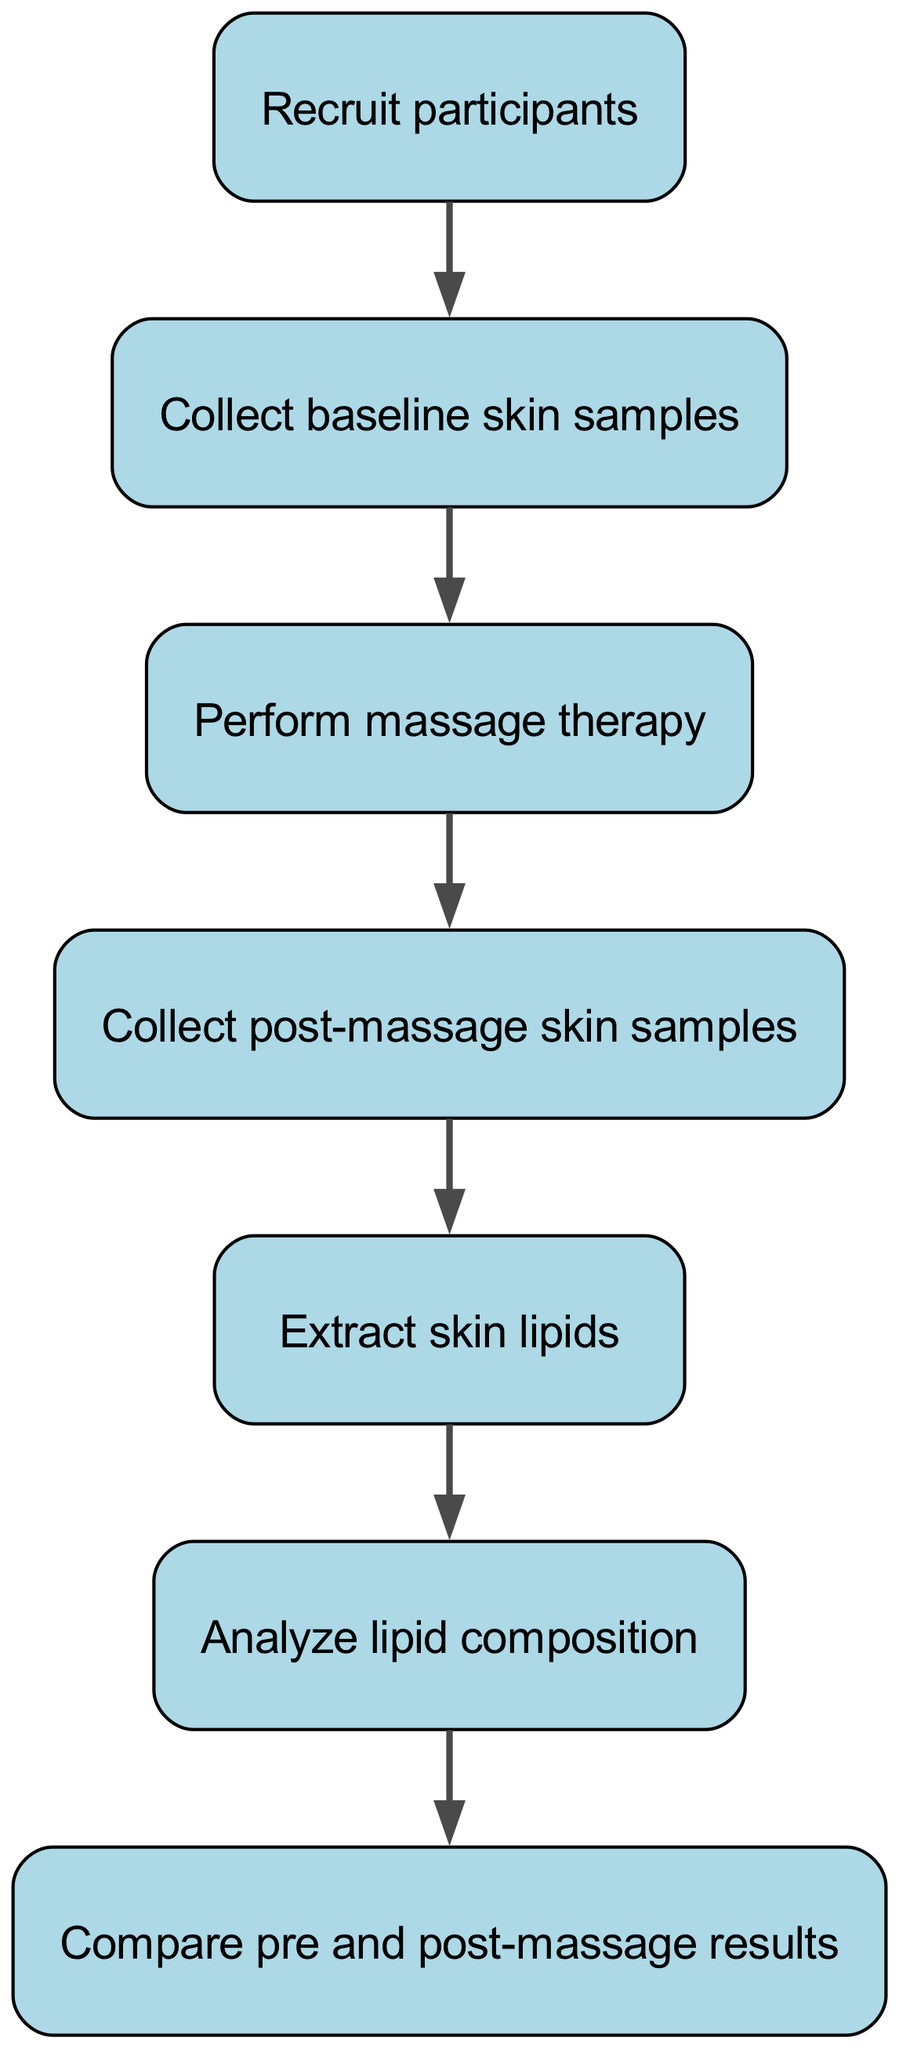What is the first step in the experimental protocol? The first node in the diagram represents the initial action of the protocol, which is recruiting participants.
Answer: Recruit participants How many nodes are present in the diagram? The diagram consists of seven distinct nodes outlining the steps in the experimental protocol.
Answer: Seven Which node follows "Collect baseline skin samples"? According to the flow of the diagram, "Perform massage therapy" directly follows the "Collect baseline skin samples" node.
Answer: Perform massage therapy What is the relationship between "Collect post-massage skin samples" and "Analyze lipid composition"? The order in the flowchart shows that "Collect post-massage skin samples" leads directly into the next step, which is "Analyze lipid composition".
Answer: Directly follows What is the final step in the experimental protocol? The last node in the flowchart depicts the step of comparing the pre and post-massage results, making it the final step.
Answer: Compare pre and post-massage results How many edges connect the nodes in the diagram? The diagram has six edges, each representing a directed connection between two steps in the experimental procedure.
Answer: Six Which nodes indicate sample collection? The nodes that indicate sample collection are "Collect baseline skin samples" and "Collect post-massage skin samples."
Answer: Collect baseline skin samples, Collect post-massage skin samples Which step immediately precedes "Analyze lipid composition"? The step that immediately precedes "Analyze lipid composition" is "Extract skin lipids," showing the direct flow in the protocol.
Answer: Extract skin lipids What does the first arrow in the flowchart represent? The first arrow represents the flow from "Recruit participants" to "Collect baseline skin samples," indicating the sequence of actions taken.
Answer: Flow from recruit participants to collect baseline skin samples 